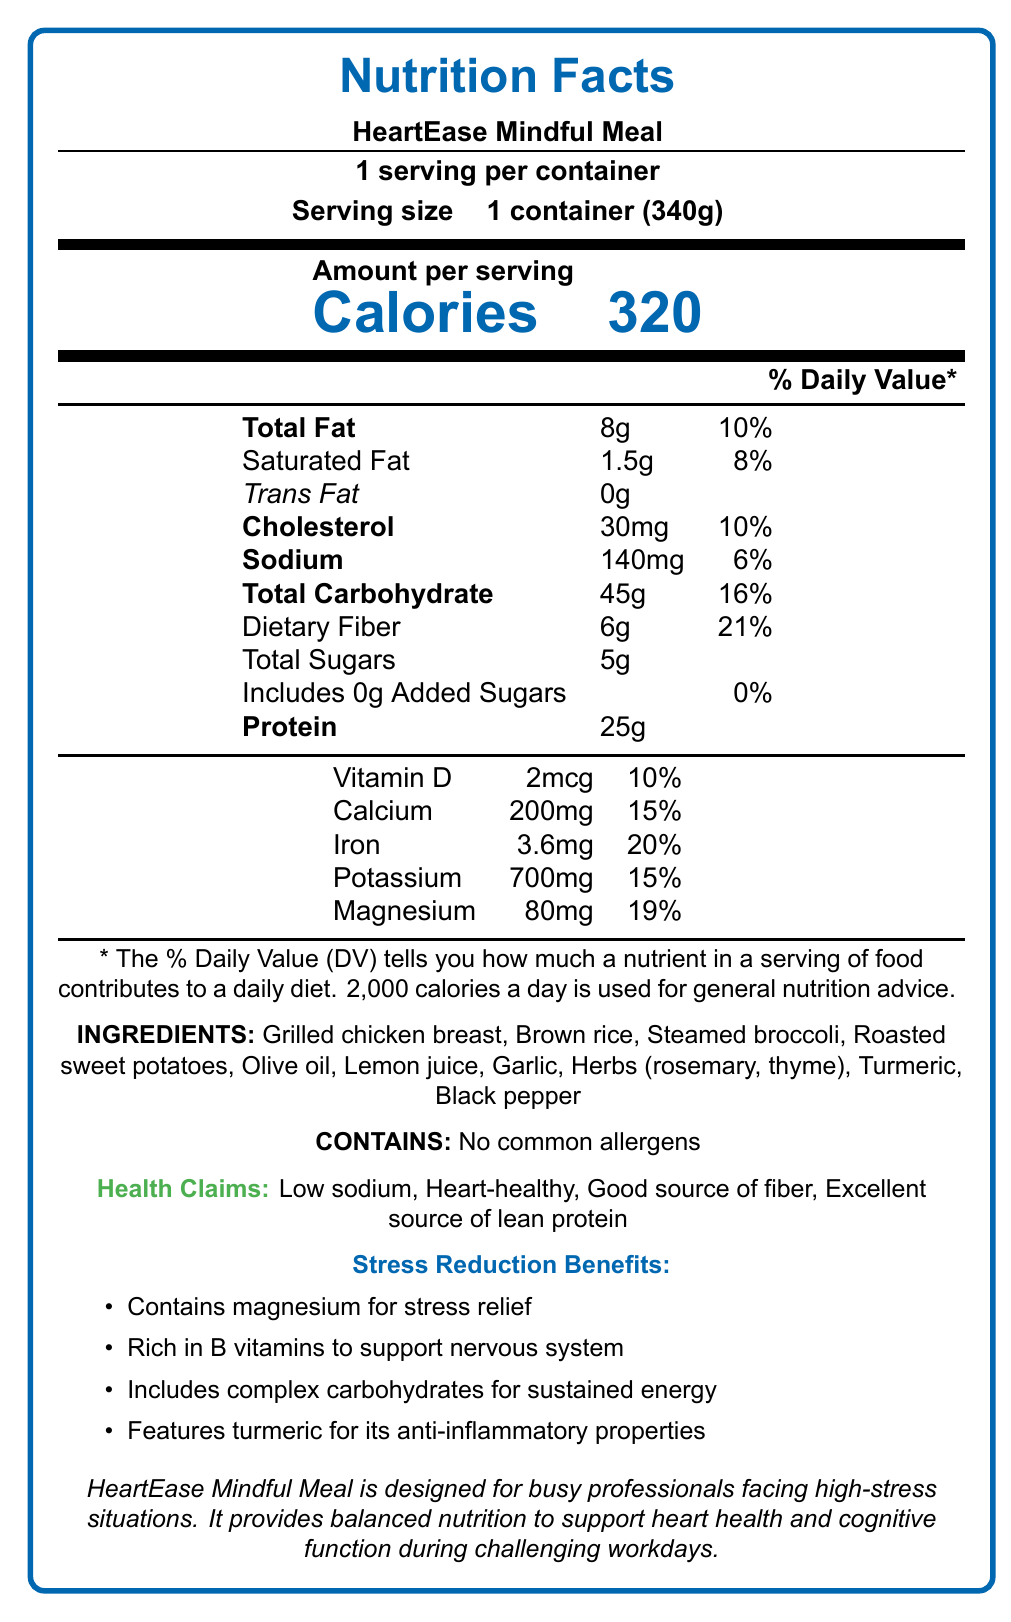what is the serving size of the HeartEase Mindful Meal? The serving size is listed as "1 container (340g)" in the document.
Answer: 1 container (340g) how many calories are in one serving of HeartEase Mindful Meal? The document states that there are 320 calories per serving.
Answer: 320 how much total fat does one serving contain? The total fat content for one serving is listed as 8g.
Answer: 8g what is the daily value percentage for dietary fiber in one serving? The daily value percentage for dietary fiber is 21%, as shown in the document.
Answer: 21% which ingredients are included in the HeartEase Mindful Meal? The ingredients are listed in the document.
Answer: Grilled chicken breast, Brown rice, Steamed broccoli, Roasted sweet potatoes, Olive oil, Lemon juice, Garlic, Herbs (rosemary, thyme), Turmeric, Black pepper what is the daily value percentage of iron in the meal? The daily value percentage for iron is indicated as 20%.
Answer: 20% how much magnesium does the meal provide? The magnesium content is listed as 80mg.
Answer: 80mg are there any common allergens in the HeartEase Mindful Meal? The document states there are no common allergens.
Answer: None which of the following health benefits are associated with HeartEase Mindful Meal? A. Low sodium B. High sugar C. Good source of fiber D. Excellent source of lean protein The health benefits listed are "Low sodium," "Good source of fiber," and "Excellent source of lean protein."
Answer: A, C, D what percentage of daily value for calcium does the HeartEase Mindful Meal provide? A. 5% B. 10% C. 15% D. 20% The meal provides 15% of the daily value for calcium.
Answer: C is HeartEase Mindful Meal designed to help reduce stress for busy professionals? The document mentions the meal is designed for busy professionals facing high-stress situations.
Answer: Yes summarize the main idea of the document. The document provides detailed nutritional information, ingredients, health claims, stress reduction benefits, and a special note on corporate wellness, focusing on balanced nutrition and stress relief.
Answer: The HeartEase Mindful Meal is a low-sodium, heart-healthy frozen dinner that provides balanced nutrition, including lean protein, fiber, and essential vitamins and minerals. It is tailored for busy professionals dealing with stress and offers benefits for heart health and cognitive function. what percentage of the daily value of vitamin D does the meal provide? The document states the meal provides 10% of the daily value for vitamin D.
Answer: 10% how much added sugar is in the HeartEase Mindful Meal? The document lists the added sugars as 0g.
Answer: 0g what ingredient is primarily used for its anti-inflammatory properties in the meal? According to the document, turmeric is mentioned for its anti-inflammatory properties.
Answer: Turmeric can the document provide information on the meal's taste or flavor profile? The document does not provide any details on the taste or flavor profile of the meal.
Answer: Not enough information 